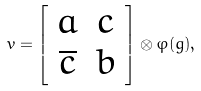<formula> <loc_0><loc_0><loc_500><loc_500>v = \left [ \begin{array} { c c } a & c \\ \overline { c } & b \end{array} \right ] \otimes \varphi ( g ) ,</formula> 